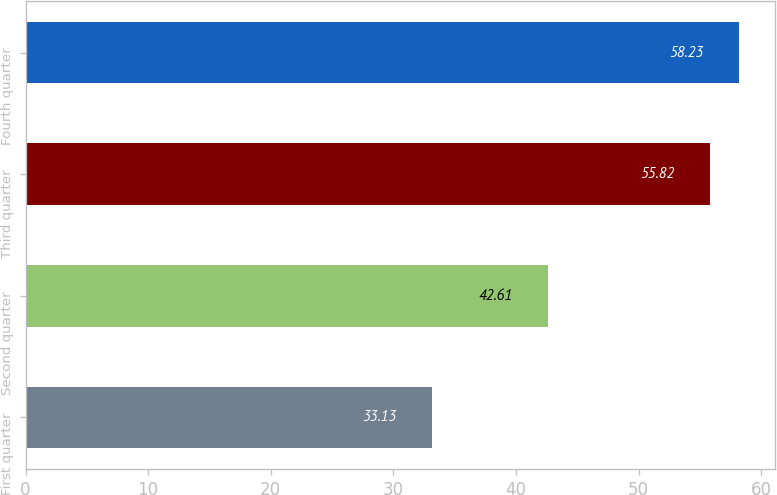Convert chart to OTSL. <chart><loc_0><loc_0><loc_500><loc_500><bar_chart><fcel>First quarter<fcel>Second quarter<fcel>Third quarter<fcel>Fourth quarter<nl><fcel>33.13<fcel>42.61<fcel>55.82<fcel>58.23<nl></chart> 